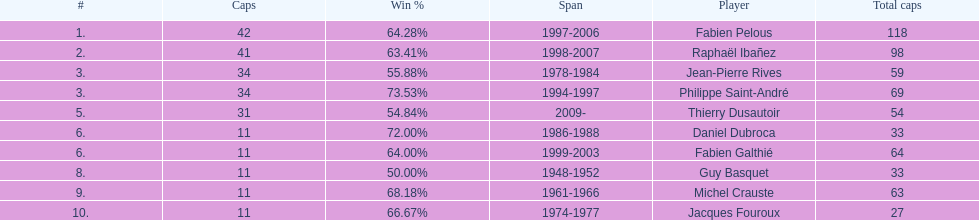Which player has the highest win percentage? Philippe Saint-André. Help me parse the entirety of this table. {'header': ['#', 'Caps', 'Win\xa0%', 'Span', 'Player', 'Total caps'], 'rows': [['1.', '42', '64.28%', '1997-2006', 'Fabien Pelous', '118'], ['2.', '41', '63.41%', '1998-2007', 'Raphaël Ibañez', '98'], ['3.', '34', '55.88%', '1978-1984', 'Jean-Pierre Rives', '59'], ['3.', '34', '73.53%', '1994-1997', 'Philippe Saint-André', '69'], ['5.', '31', '54.84%', '2009-', 'Thierry Dusautoir', '54'], ['6.', '11', '72.00%', '1986-1988', 'Daniel Dubroca', '33'], ['6.', '11', '64.00%', '1999-2003', 'Fabien Galthié', '64'], ['8.', '11', '50.00%', '1948-1952', 'Guy Basquet', '33'], ['9.', '11', '68.18%', '1961-1966', 'Michel Crauste', '63'], ['10.', '11', '66.67%', '1974-1977', 'Jacques Fouroux', '27']]} 